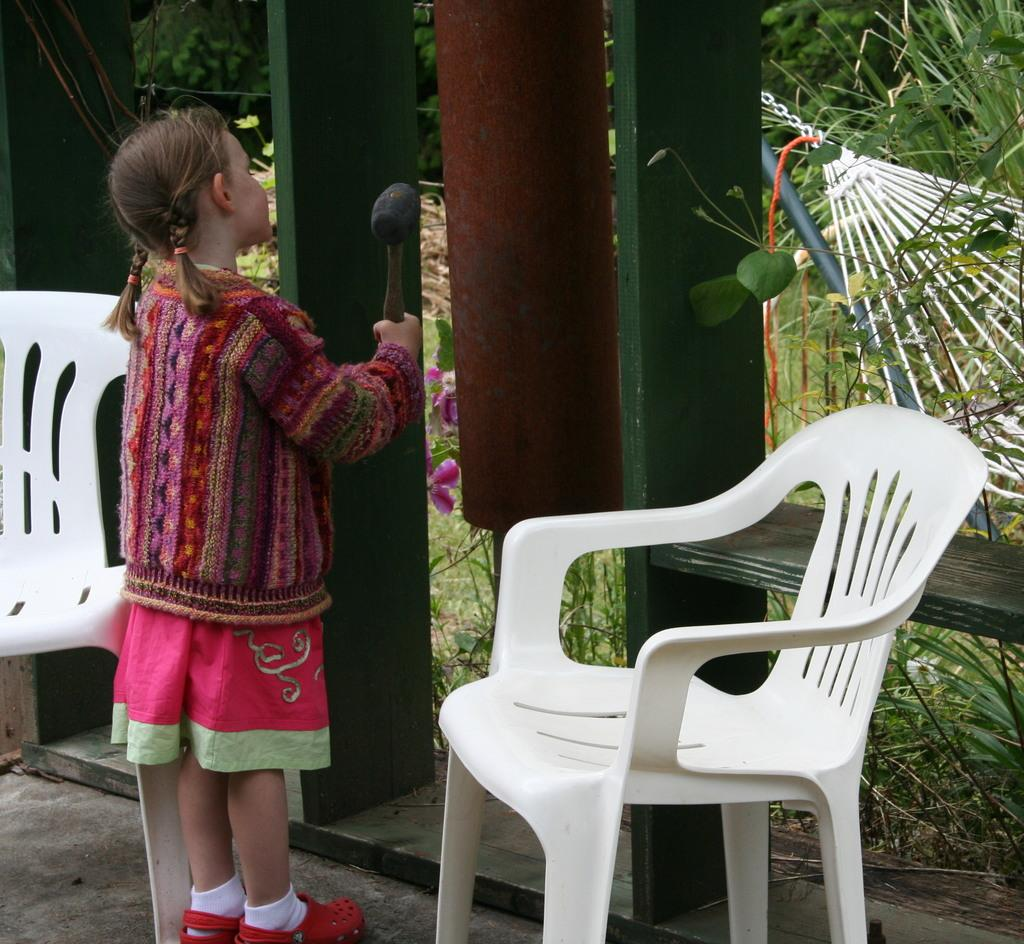Who is the main subject in the image? There is a girl in the image. What is the girl holding in the image? The girl is holding a hammer. What is the girl wearing in the image? The girl is wearing a jacket. What type of furniture can be seen in the image? There are white chairs in the image. What type of vegetation is visible in the image? There are plants visible in the image. What type of food is the girl eating in the image? There is no food present in the image; the girl is holding a hammer. What type of behavior is the girl exhibiting in the image? The image does not provide information about the girl's behavior, only her appearance and the objects she is holding. 